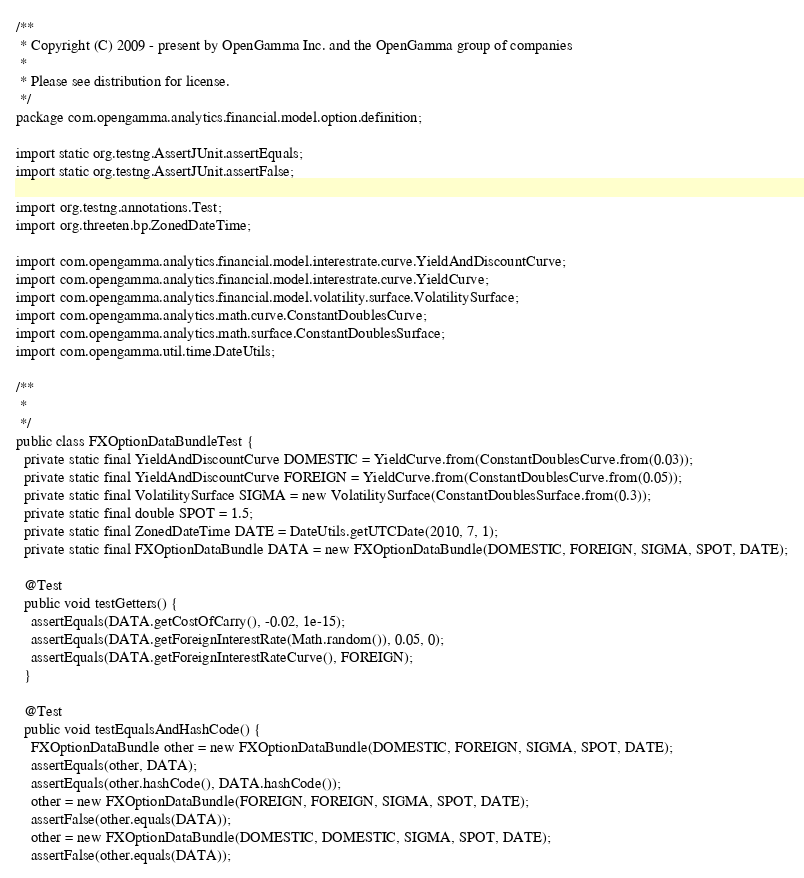<code> <loc_0><loc_0><loc_500><loc_500><_Java_>/**
 * Copyright (C) 2009 - present by OpenGamma Inc. and the OpenGamma group of companies
 * 
 * Please see distribution for license.
 */
package com.opengamma.analytics.financial.model.option.definition;

import static org.testng.AssertJUnit.assertEquals;
import static org.testng.AssertJUnit.assertFalse;

import org.testng.annotations.Test;
import org.threeten.bp.ZonedDateTime;

import com.opengamma.analytics.financial.model.interestrate.curve.YieldAndDiscountCurve;
import com.opengamma.analytics.financial.model.interestrate.curve.YieldCurve;
import com.opengamma.analytics.financial.model.volatility.surface.VolatilitySurface;
import com.opengamma.analytics.math.curve.ConstantDoublesCurve;
import com.opengamma.analytics.math.surface.ConstantDoublesSurface;
import com.opengamma.util.time.DateUtils;

/**
 * 
 */
public class FXOptionDataBundleTest {
  private static final YieldAndDiscountCurve DOMESTIC = YieldCurve.from(ConstantDoublesCurve.from(0.03));
  private static final YieldAndDiscountCurve FOREIGN = YieldCurve.from(ConstantDoublesCurve.from(0.05));
  private static final VolatilitySurface SIGMA = new VolatilitySurface(ConstantDoublesSurface.from(0.3));
  private static final double SPOT = 1.5;
  private static final ZonedDateTime DATE = DateUtils.getUTCDate(2010, 7, 1);
  private static final FXOptionDataBundle DATA = new FXOptionDataBundle(DOMESTIC, FOREIGN, SIGMA, SPOT, DATE);

  @Test
  public void testGetters() {
    assertEquals(DATA.getCostOfCarry(), -0.02, 1e-15);
    assertEquals(DATA.getForeignInterestRate(Math.random()), 0.05, 0);
    assertEquals(DATA.getForeignInterestRateCurve(), FOREIGN);
  }

  @Test
  public void testEqualsAndHashCode() {
    FXOptionDataBundle other = new FXOptionDataBundle(DOMESTIC, FOREIGN, SIGMA, SPOT, DATE);
    assertEquals(other, DATA);
    assertEquals(other.hashCode(), DATA.hashCode());
    other = new FXOptionDataBundle(FOREIGN, FOREIGN, SIGMA, SPOT, DATE);
    assertFalse(other.equals(DATA));
    other = new FXOptionDataBundle(DOMESTIC, DOMESTIC, SIGMA, SPOT, DATE);
    assertFalse(other.equals(DATA));</code> 